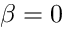Convert formula to latex. <formula><loc_0><loc_0><loc_500><loc_500>\beta = 0</formula> 